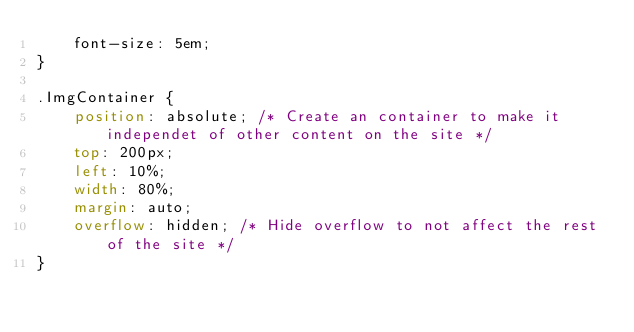<code> <loc_0><loc_0><loc_500><loc_500><_CSS_>    font-size: 5em;
}

.ImgContainer {
    position: absolute; /* Create an container to make it independet of other content on the site */
    top: 200px;
    left: 10%;
    width: 80%;
    margin: auto;
    overflow: hidden; /* Hide overflow to not affect the rest of the site */
}</code> 